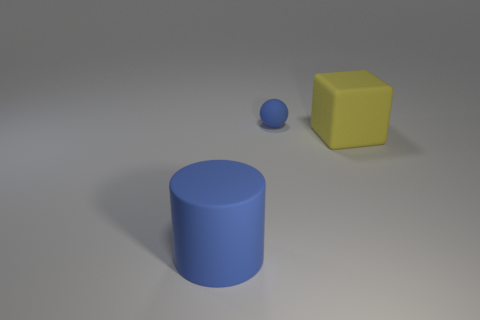The matte cylinder has what size?
Your answer should be very brief. Large. There is a large thing that is to the right of the blue matte thing in front of the thing that is behind the large block; what color is it?
Make the answer very short. Yellow. There is a thing behind the yellow rubber thing; is it the same color as the cube?
Make the answer very short. No. How many large matte things are to the left of the yellow cube and on the right side of the large blue cylinder?
Give a very brief answer. 0. There is a tiny blue ball that is on the right side of the blue rubber object in front of the tiny blue object; what number of big yellow objects are behind it?
Provide a succinct answer. 0. What color is the big thing that is left of the big rubber object that is right of the big blue rubber cylinder?
Make the answer very short. Blue. What number of other objects are there of the same material as the tiny thing?
Keep it short and to the point. 2. How many yellow blocks are to the left of the large matte thing on the left side of the yellow matte object?
Provide a short and direct response. 0. Is there any other thing that has the same shape as the large blue thing?
Ensure brevity in your answer.  No. There is a object that is in front of the large yellow rubber block; is its color the same as the thing that is behind the yellow block?
Give a very brief answer. Yes. 